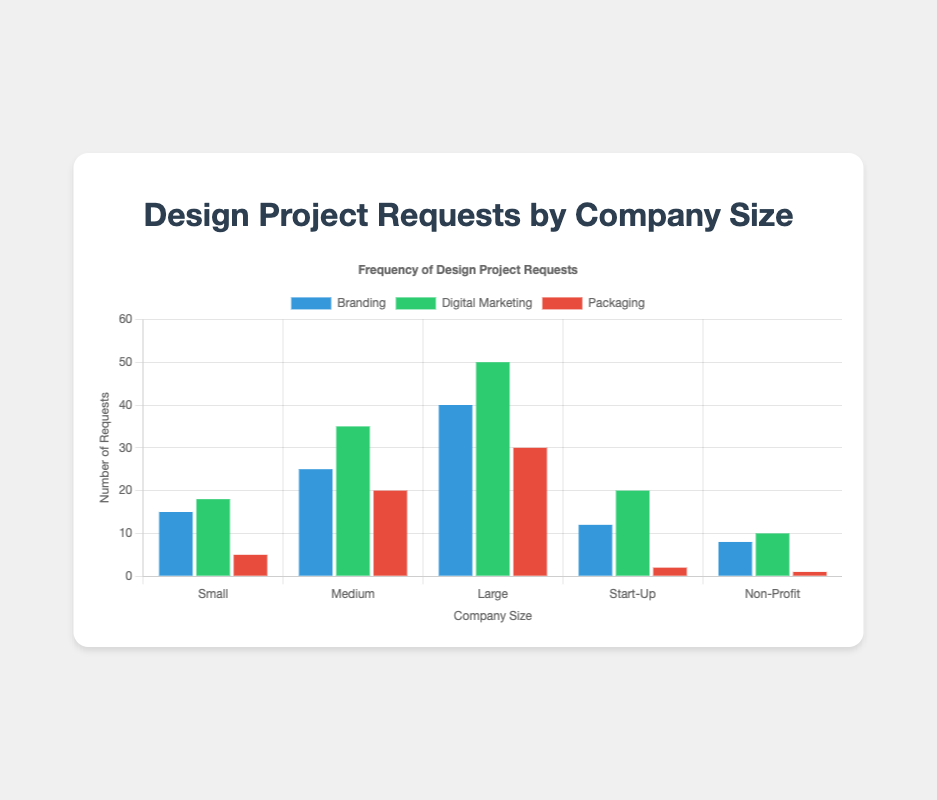What project type has the most requests from large companies? Look at the bars for "Large" companies. The tallest bar corresponds to "Digital Marketing" with 50 requests.
Answer: Digital Marketing Which company type has the least number of packaging requests? Look at the "Packaging" bars. The shortest bar corresponds to "Non-Profit" companies with just 1 request.
Answer: Non-Profit What is the total number of branding requests from all companies combined? Sum the values from the "Branding" dataset: 15 (Small) + 25 (Medium) + 40 (Large) + 12 (Start-Up) + 8 (Non-Profit) = 100
Answer: 100 Compare the number of digital marketing and branding requests for medium-sized companies. Look at the bars for "Medium" companies. The bar for "Digital Marketing" shows 35 requests and the bar for "Branding" shows 25 requests. Digital Marketing is higher.
Answer: Digital Marketing For start-up companies, how many more times the digital marketing requests are compared to packaging requests? The number of digital marketing requests for start-up companies is 20, and packaging requests is 2. The ratio is 20 / 2 = 10 times.
Answer: 10 times Which company size has the greatest overall request for all project types? Sum the values for each project type for each company size. Large company: 40 (Branding) + 50 (Digital Marketing) + 30 (Packaging) = 120. This is the highest total.
Answer: Large What is the difference in digital marketing requests between small and large companies? Subtract the number of digital marketing requests for small companies (18) from that for large companies (50). 50 - 18 = 32
Answer: 32 How many more packaging requests are there for medium companies compared to small companies? Subtract the number of packaging requests for small companies (5) from that for medium companies (20). 20 - 5 = 15
Answer: 15 What is the average number of requests for branding across all company sizes? Sum the values for branding and then divide by the number of companies: (15 + 25 + 40 + 12 + 8) / 5 = 20
Answer: 20 Which company sizes have more than 30 total requests for digital marketing and packaging combined? Calculate the sum of digital marketing and packaging requests for each company. Large: 50 (Digital Marketing) + 30 (Packaging) = 80. Medium: 35 (Digital Marketing) + 20 (Packaging) = 55. Both totals are more than 30.
Answer: Large, Medium 